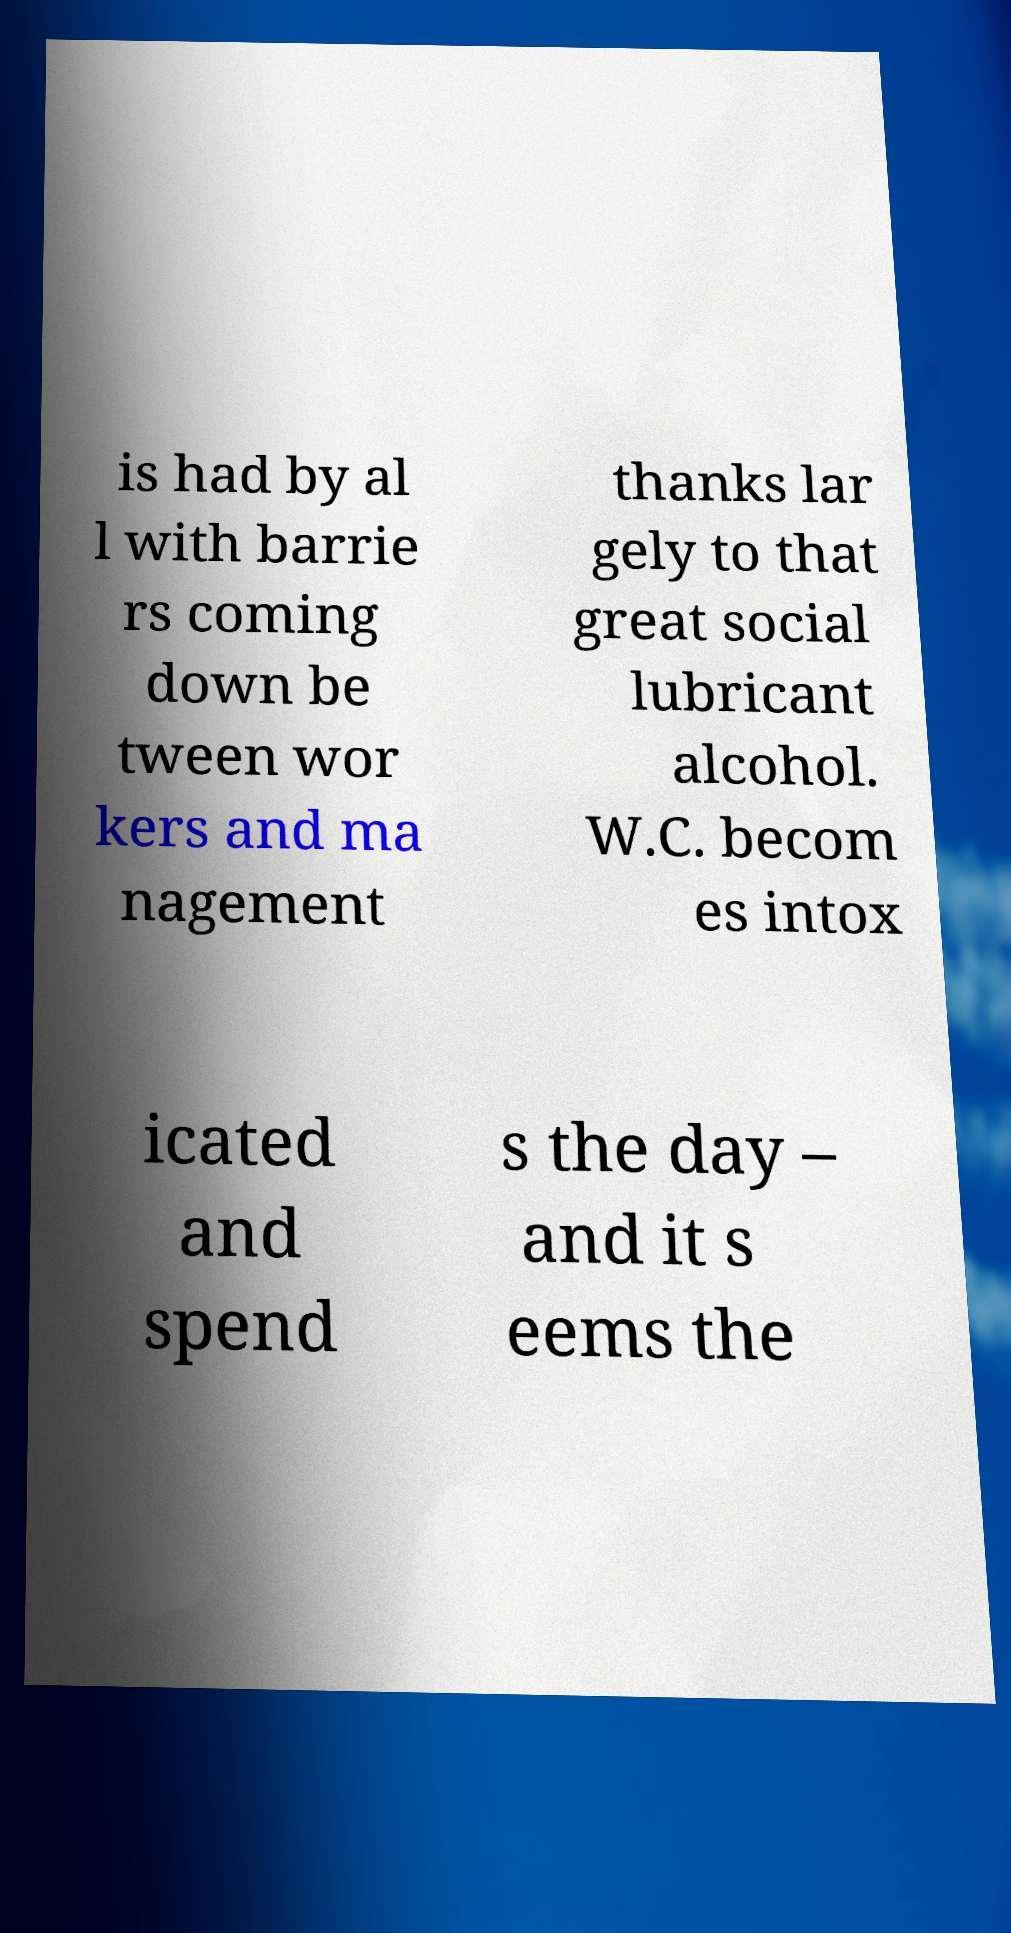Please read and relay the text visible in this image. What does it say? is had by al l with barrie rs coming down be tween wor kers and ma nagement thanks lar gely to that great social lubricant alcohol. W.C. becom es intox icated and spend s the day – and it s eems the 